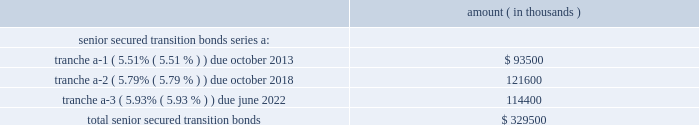Entergy corporation and subsidiaries notes to financial statements entergy new orleans securitization bonds - hurricane isaac in may 2015 the city council issued a financing order authorizing the issuance of securitization bonds to recover entergy new orleans 2019s hurricane isaac storm restoration costs of $ 31.8 million , including carrying costs , the costs of funding and replenishing the storm recovery reserve in the amount of $ 63.9 million , and approximately $ 3 million of up-front financing costs associated with the securitization .
In july 2015 , entergy new orleans storm recovery funding i , l.l.c. , a company wholly owned and consolidated by entergy new orleans , issued $ 98.7 million of storm cost recovery bonds .
The bonds have a coupon of 2.67% ( 2.67 % ) and an expected maturity date of june 2024 .
Although the principal amount is not due until the date given above , entergy new orleans storm recovery funding expects to make principal payments on the bonds over the next five years in the amounts of $ 11.4 million for 2016 , $ 10.6 million for 2017 , $ 11 million for 2018 , $ 11.2 million for 2019 , and $ 11.6 million for 2020 .
With the proceeds , entergy new orleans storm recovery funding purchased from entergy new orleans the storm recovery property , which is the right to recover from customers through a storm recovery charge amounts sufficient to service the securitization bonds .
The storm recovery property is reflected as a regulatory asset on the consolidated entergy new orleans balance sheet .
The creditors of entergy new orleans do not have recourse to the assets or revenues of entergy new orleans storm recovery funding , including the storm recovery property , and the creditors of entergy new orleans storm recovery funding do not have recourse to the assets or revenues of entergy new orleans .
Entergy new orleans has no payment obligations to entergy new orleans storm recovery funding except to remit storm recovery charge collections .
Entergy texas securitization bonds - hurricane rita in april 2007 the puct issued a financing order authorizing the issuance of securitization bonds to recover $ 353 million of entergy texas 2019s hurricane rita reconstruction costs and up to $ 6 million of transaction costs , offset by $ 32 million of related deferred income tax benefits .
In june 2007 , entergy gulf states reconstruction funding i , llc , a company that is now wholly-owned and consolidated by entergy texas , issued $ 329.5 million of senior secured transition bonds ( securitization bonds ) as follows : amount ( in thousands ) .
Although the principal amount of each tranche is not due until the dates given above , entergy gulf states reconstruction funding expects to make principal payments on the bonds over the next five years in the amounts of $ 26 million for 2016 , $ 27.6 million for 2017 , $ 29.2 million for 2018 , $ 30.9 million for 2019 , and $ 32.8 million for 2020 .
All of the scheduled principal payments for 2016 are for tranche a-2 , $ 23.6 million of the scheduled principal payments for 2017 are for tranche a-2 and $ 4 million of the scheduled principal payments for 2017 are for tranche a-3 .
All of the scheduled principal payments for 2018-2020 are for tranche a-3 .
With the proceeds , entergy gulf states reconstruction funding purchased from entergy texas the transition property , which is the right to recover from customers through a transition charge amounts sufficient to service the securitization bonds .
The transition property is reflected as a regulatory asset on the consolidated entergy texas balance sheet .
The creditors of entergy texas do not have recourse to the assets or revenues of entergy gulf states reconstruction funding , including the transition property , and the creditors of entergy gulf states reconstruction funding do not have recourse to the assets or revenues of entergy texas .
Entergy texas has no payment obligations to entergy gulf states reconstruction funding except to remit transition charge collections. .
What is the principal payment in 2020 as a percentage of the total senior secured transition bonds? 
Computations: ((32.8 * 1000) / 329500)
Answer: 0.09954. Entergy corporation and subsidiaries notes to financial statements entergy new orleans securitization bonds - hurricane isaac in may 2015 the city council issued a financing order authorizing the issuance of securitization bonds to recover entergy new orleans 2019s hurricane isaac storm restoration costs of $ 31.8 million , including carrying costs , the costs of funding and replenishing the storm recovery reserve in the amount of $ 63.9 million , and approximately $ 3 million of up-front financing costs associated with the securitization .
In july 2015 , entergy new orleans storm recovery funding i , l.l.c. , a company wholly owned and consolidated by entergy new orleans , issued $ 98.7 million of storm cost recovery bonds .
The bonds have a coupon of 2.67% ( 2.67 % ) and an expected maturity date of june 2024 .
Although the principal amount is not due until the date given above , entergy new orleans storm recovery funding expects to make principal payments on the bonds over the next five years in the amounts of $ 11.4 million for 2016 , $ 10.6 million for 2017 , $ 11 million for 2018 , $ 11.2 million for 2019 , and $ 11.6 million for 2020 .
With the proceeds , entergy new orleans storm recovery funding purchased from entergy new orleans the storm recovery property , which is the right to recover from customers through a storm recovery charge amounts sufficient to service the securitization bonds .
The storm recovery property is reflected as a regulatory asset on the consolidated entergy new orleans balance sheet .
The creditors of entergy new orleans do not have recourse to the assets or revenues of entergy new orleans storm recovery funding , including the storm recovery property , and the creditors of entergy new orleans storm recovery funding do not have recourse to the assets or revenues of entergy new orleans .
Entergy new orleans has no payment obligations to entergy new orleans storm recovery funding except to remit storm recovery charge collections .
Entergy texas securitization bonds - hurricane rita in april 2007 the puct issued a financing order authorizing the issuance of securitization bonds to recover $ 353 million of entergy texas 2019s hurricane rita reconstruction costs and up to $ 6 million of transaction costs , offset by $ 32 million of related deferred income tax benefits .
In june 2007 , entergy gulf states reconstruction funding i , llc , a company that is now wholly-owned and consolidated by entergy texas , issued $ 329.5 million of senior secured transition bonds ( securitization bonds ) as follows : amount ( in thousands ) .
Although the principal amount of each tranche is not due until the dates given above , entergy gulf states reconstruction funding expects to make principal payments on the bonds over the next five years in the amounts of $ 26 million for 2016 , $ 27.6 million for 2017 , $ 29.2 million for 2018 , $ 30.9 million for 2019 , and $ 32.8 million for 2020 .
All of the scheduled principal payments for 2016 are for tranche a-2 , $ 23.6 million of the scheduled principal payments for 2017 are for tranche a-2 and $ 4 million of the scheduled principal payments for 2017 are for tranche a-3 .
All of the scheduled principal payments for 2018-2020 are for tranche a-3 .
With the proceeds , entergy gulf states reconstruction funding purchased from entergy texas the transition property , which is the right to recover from customers through a transition charge amounts sufficient to service the securitization bonds .
The transition property is reflected as a regulatory asset on the consolidated entergy texas balance sheet .
The creditors of entergy texas do not have recourse to the assets or revenues of entergy gulf states reconstruction funding , including the transition property , and the creditors of entergy gulf states reconstruction funding do not have recourse to the assets or revenues of entergy texas .
Entergy texas has no payment obligations to entergy gulf states reconstruction funding except to remit transition charge collections. .
What was the ratio of the scheduled principal payments in 2017 for tranche a-2 to a-3? 
Computations: (23.6 / 4)
Answer: 5.9. 